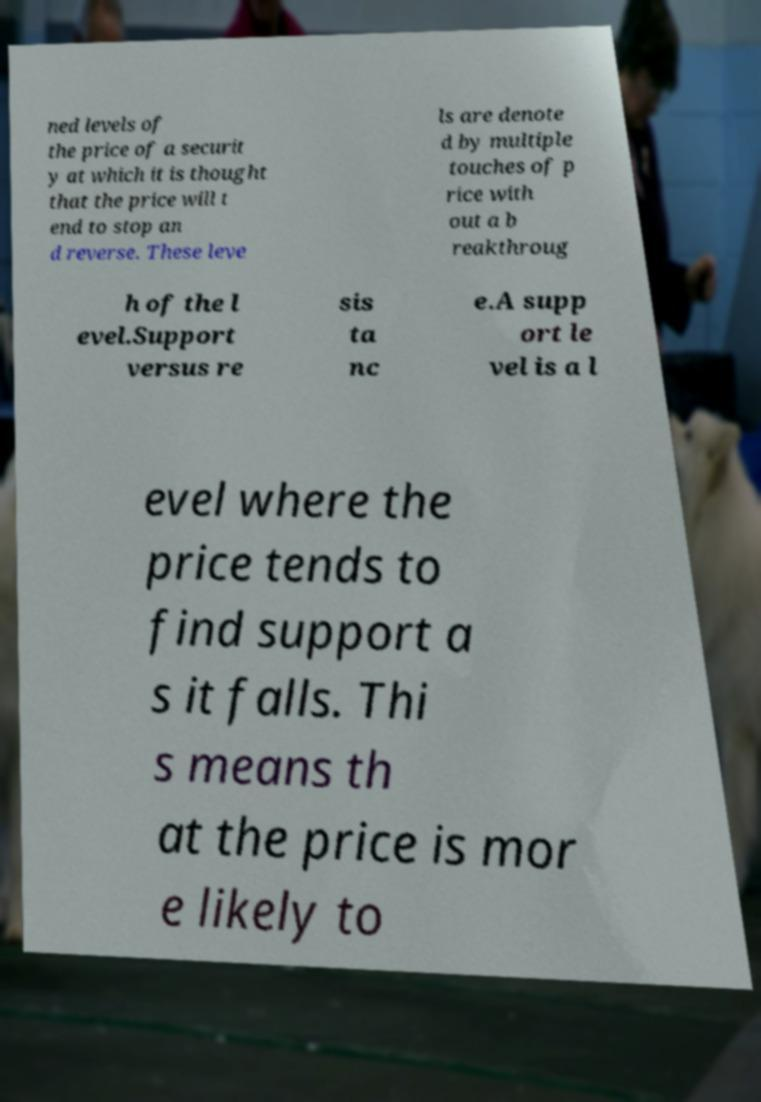Could you extract and type out the text from this image? ned levels of the price of a securit y at which it is thought that the price will t end to stop an d reverse. These leve ls are denote d by multiple touches of p rice with out a b reakthroug h of the l evel.Support versus re sis ta nc e.A supp ort le vel is a l evel where the price tends to find support a s it falls. Thi s means th at the price is mor e likely to 